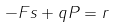<formula> <loc_0><loc_0><loc_500><loc_500>- F s + q P = r</formula> 